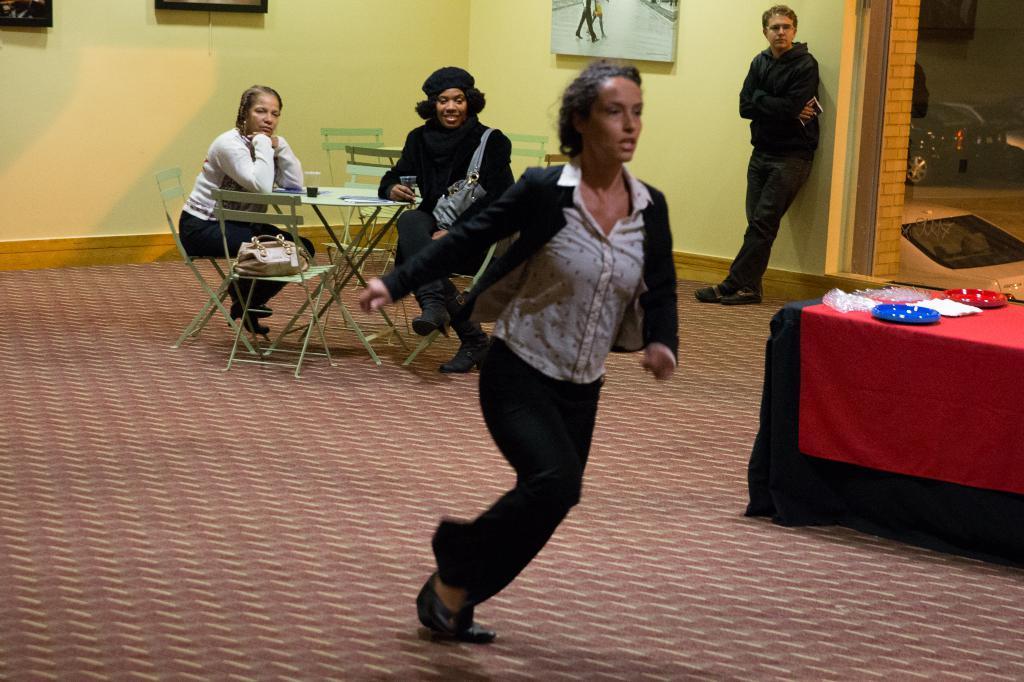Describe this image in one or two sentences. In the center of the image we can see a woman running on the floor. In the background there is a man standing. We can also see two persons sitting on the chairs in front of the table. We can also see the glass of drink, bag and also the frames attached to the plain wall. On the right we can see the table which is covered with the black and red color clothes. We can also see the plates, tissues and also the covers on the table. We can also see the glass door and through the glass door we can see the vehicle on the road. 